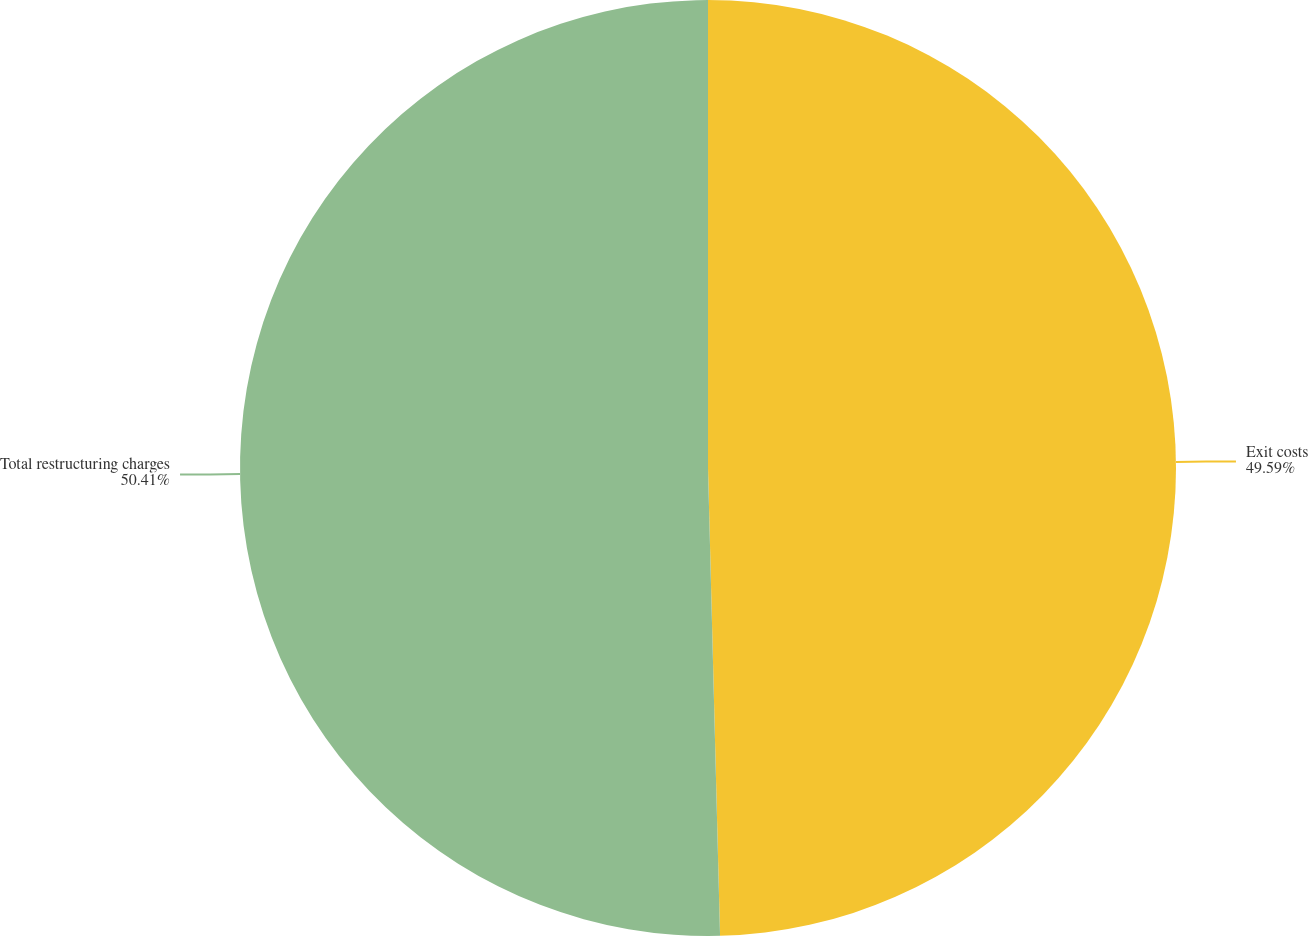Convert chart. <chart><loc_0><loc_0><loc_500><loc_500><pie_chart><fcel>Exit costs<fcel>Total restructuring charges<nl><fcel>49.59%<fcel>50.41%<nl></chart> 